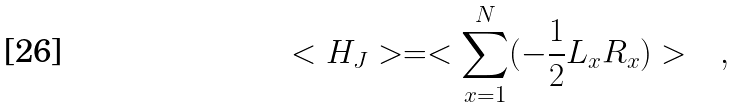<formula> <loc_0><loc_0><loc_500><loc_500>< H _ { J } > = < \sum _ { x = 1 } ^ { N } ( - \frac { 1 } { 2 } L _ { x } R _ { x } ) > \quad ,</formula> 